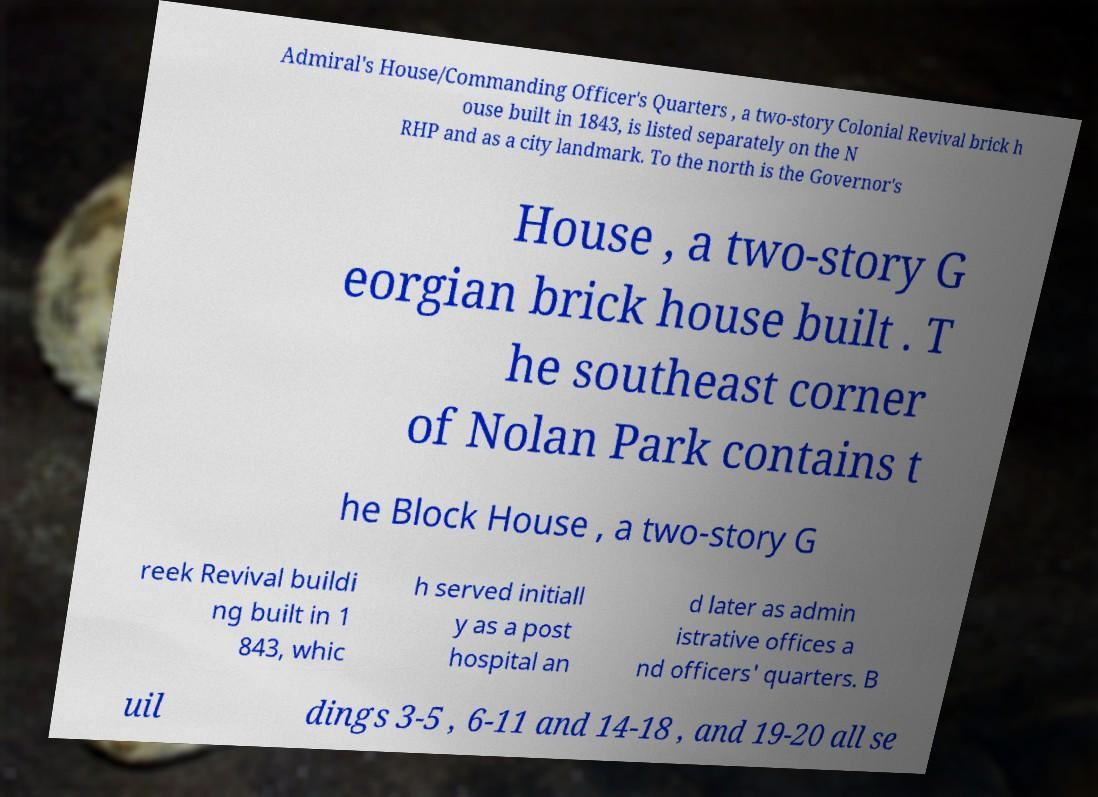There's text embedded in this image that I need extracted. Can you transcribe it verbatim? Admiral's House/Commanding Officer's Quarters , a two-story Colonial Revival brick h ouse built in 1843, is listed separately on the N RHP and as a city landmark. To the north is the Governor's House , a two-story G eorgian brick house built . T he southeast corner of Nolan Park contains t he Block House , a two-story G reek Revival buildi ng built in 1 843, whic h served initiall y as a post hospital an d later as admin istrative offices a nd officers' quarters. B uil dings 3-5 , 6-11 and 14-18 , and 19-20 all se 